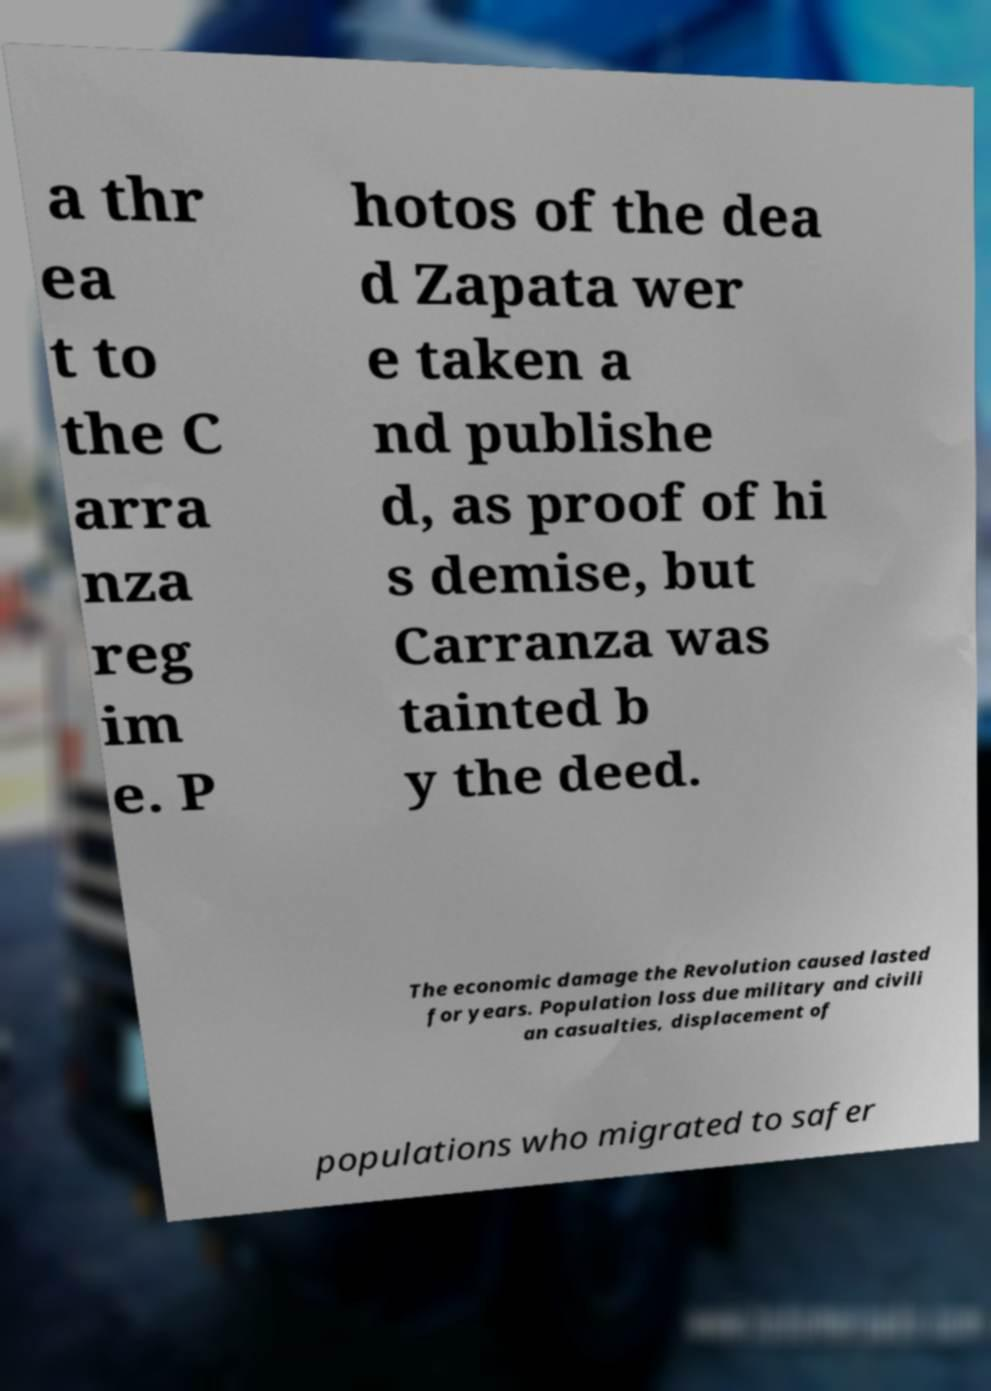Can you accurately transcribe the text from the provided image for me? a thr ea t to the C arra nza reg im e. P hotos of the dea d Zapata wer e taken a nd publishe d, as proof of hi s demise, but Carranza was tainted b y the deed. The economic damage the Revolution caused lasted for years. Population loss due military and civili an casualties, displacement of populations who migrated to safer 